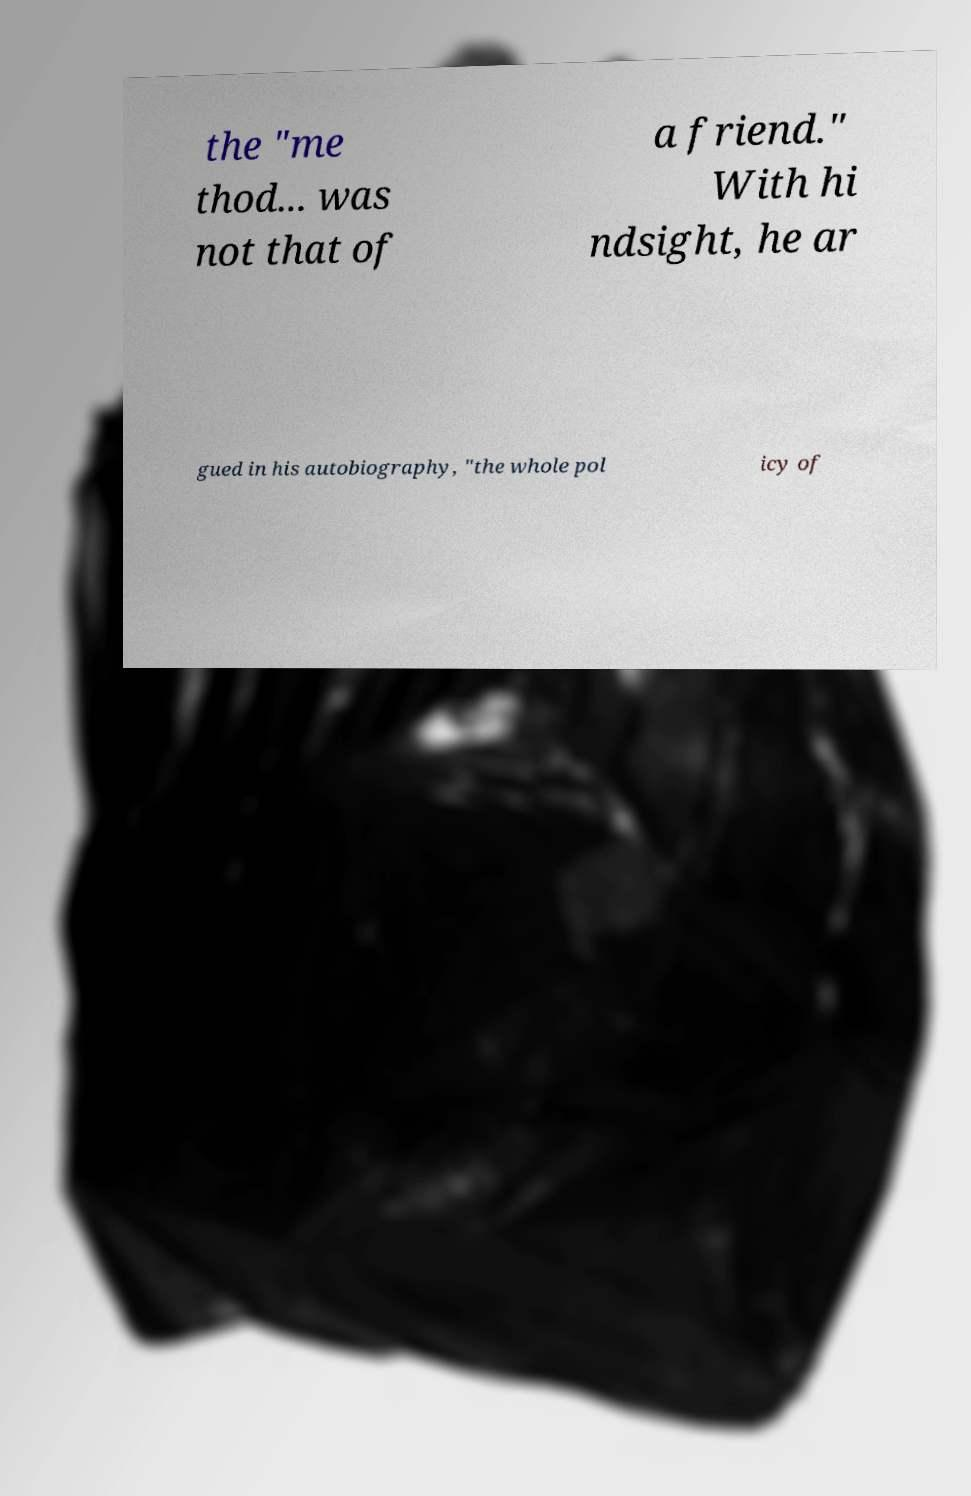Please read and relay the text visible in this image. What does it say? the "me thod... was not that of a friend." With hi ndsight, he ar gued in his autobiography, "the whole pol icy of 